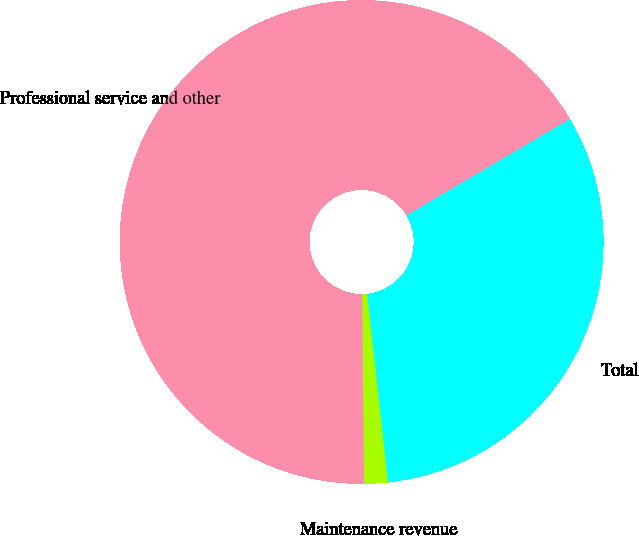<chart> <loc_0><loc_0><loc_500><loc_500><pie_chart><fcel>Maintenance revenue<fcel>Professional service and other<fcel>Total<nl><fcel>1.59%<fcel>66.67%<fcel>31.75%<nl></chart> 